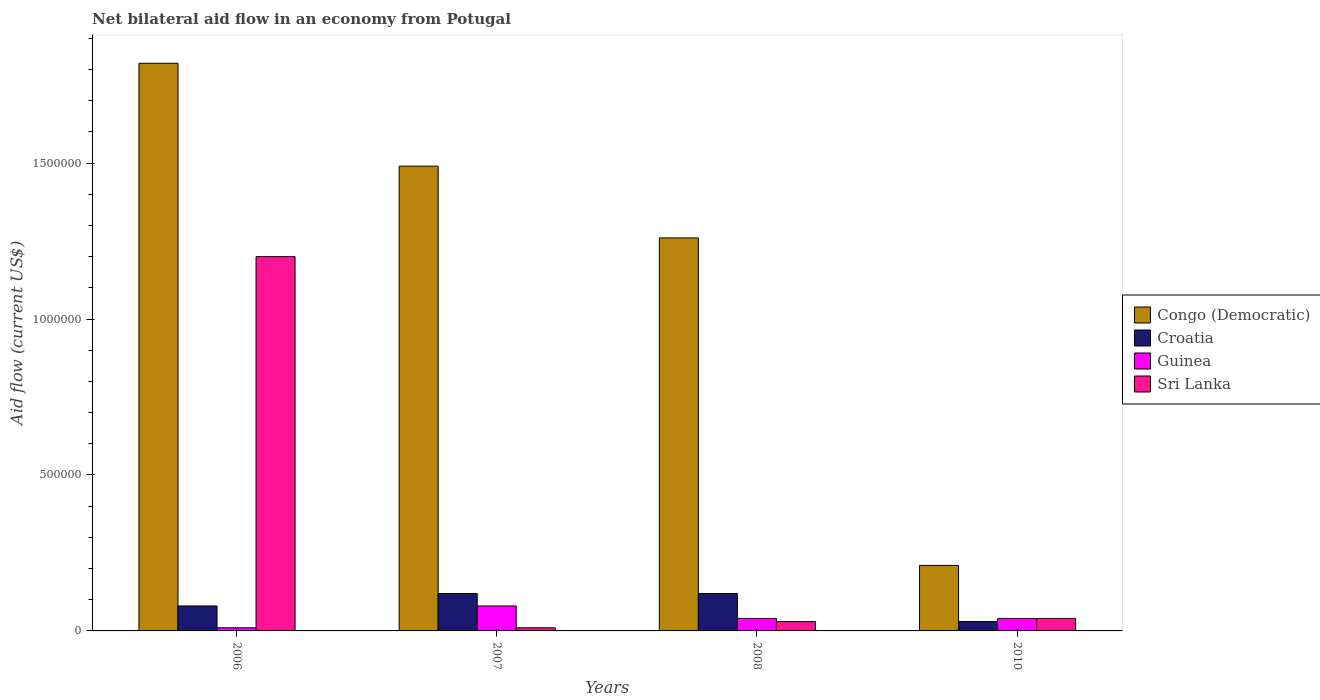How many different coloured bars are there?
Keep it short and to the point. 4. What is the label of the 2nd group of bars from the left?
Your response must be concise. 2007. In how many cases, is the number of bars for a given year not equal to the number of legend labels?
Your response must be concise. 0. Across all years, what is the maximum net bilateral aid flow in Guinea?
Your answer should be very brief. 8.00e+04. Across all years, what is the minimum net bilateral aid flow in Guinea?
Offer a very short reply. 10000. In which year was the net bilateral aid flow in Croatia maximum?
Provide a succinct answer. 2007. What is the total net bilateral aid flow in Sri Lanka in the graph?
Your answer should be compact. 1.28e+06. What is the difference between the net bilateral aid flow in Sri Lanka in 2007 and that in 2010?
Your answer should be compact. -3.00e+04. What is the difference between the net bilateral aid flow in Congo (Democratic) in 2008 and the net bilateral aid flow in Guinea in 2006?
Provide a short and direct response. 1.25e+06. What is the average net bilateral aid flow in Congo (Democratic) per year?
Your answer should be compact. 1.20e+06. In how many years, is the net bilateral aid flow in Sri Lanka greater than 1300000 US$?
Make the answer very short. 0. What is the ratio of the net bilateral aid flow in Guinea in 2008 to that in 2010?
Give a very brief answer. 1. What is the difference between the highest and the lowest net bilateral aid flow in Guinea?
Your answer should be compact. 7.00e+04. In how many years, is the net bilateral aid flow in Croatia greater than the average net bilateral aid flow in Croatia taken over all years?
Ensure brevity in your answer.  2. Is it the case that in every year, the sum of the net bilateral aid flow in Guinea and net bilateral aid flow in Sri Lanka is greater than the sum of net bilateral aid flow in Congo (Democratic) and net bilateral aid flow in Croatia?
Give a very brief answer. No. What does the 3rd bar from the left in 2010 represents?
Give a very brief answer. Guinea. What does the 1st bar from the right in 2010 represents?
Ensure brevity in your answer.  Sri Lanka. How many years are there in the graph?
Provide a succinct answer. 4. Are the values on the major ticks of Y-axis written in scientific E-notation?
Offer a terse response. No. Does the graph contain any zero values?
Offer a very short reply. No. Does the graph contain grids?
Your response must be concise. No. Where does the legend appear in the graph?
Make the answer very short. Center right. How many legend labels are there?
Ensure brevity in your answer.  4. How are the legend labels stacked?
Provide a succinct answer. Vertical. What is the title of the graph?
Ensure brevity in your answer.  Net bilateral aid flow in an economy from Potugal. Does "Turkey" appear as one of the legend labels in the graph?
Your answer should be compact. No. What is the label or title of the X-axis?
Give a very brief answer. Years. What is the label or title of the Y-axis?
Ensure brevity in your answer.  Aid flow (current US$). What is the Aid flow (current US$) of Congo (Democratic) in 2006?
Offer a very short reply. 1.82e+06. What is the Aid flow (current US$) in Croatia in 2006?
Make the answer very short. 8.00e+04. What is the Aid flow (current US$) of Sri Lanka in 2006?
Your answer should be compact. 1.20e+06. What is the Aid flow (current US$) of Congo (Democratic) in 2007?
Provide a succinct answer. 1.49e+06. What is the Aid flow (current US$) of Congo (Democratic) in 2008?
Provide a short and direct response. 1.26e+06. What is the Aid flow (current US$) of Croatia in 2008?
Ensure brevity in your answer.  1.20e+05. What is the Aid flow (current US$) of Guinea in 2008?
Your answer should be compact. 4.00e+04. What is the Aid flow (current US$) of Sri Lanka in 2008?
Provide a succinct answer. 3.00e+04. What is the Aid flow (current US$) in Congo (Democratic) in 2010?
Your answer should be compact. 2.10e+05. What is the Aid flow (current US$) in Croatia in 2010?
Provide a short and direct response. 3.00e+04. Across all years, what is the maximum Aid flow (current US$) in Congo (Democratic)?
Ensure brevity in your answer.  1.82e+06. Across all years, what is the maximum Aid flow (current US$) of Croatia?
Your answer should be compact. 1.20e+05. Across all years, what is the maximum Aid flow (current US$) in Guinea?
Give a very brief answer. 8.00e+04. Across all years, what is the maximum Aid flow (current US$) in Sri Lanka?
Provide a short and direct response. 1.20e+06. Across all years, what is the minimum Aid flow (current US$) of Guinea?
Give a very brief answer. 10000. Across all years, what is the minimum Aid flow (current US$) of Sri Lanka?
Keep it short and to the point. 10000. What is the total Aid flow (current US$) in Congo (Democratic) in the graph?
Your response must be concise. 4.78e+06. What is the total Aid flow (current US$) in Guinea in the graph?
Offer a terse response. 1.70e+05. What is the total Aid flow (current US$) of Sri Lanka in the graph?
Your answer should be very brief. 1.28e+06. What is the difference between the Aid flow (current US$) in Guinea in 2006 and that in 2007?
Offer a very short reply. -7.00e+04. What is the difference between the Aid flow (current US$) of Sri Lanka in 2006 and that in 2007?
Your answer should be compact. 1.19e+06. What is the difference between the Aid flow (current US$) of Congo (Democratic) in 2006 and that in 2008?
Provide a succinct answer. 5.60e+05. What is the difference between the Aid flow (current US$) of Sri Lanka in 2006 and that in 2008?
Give a very brief answer. 1.17e+06. What is the difference between the Aid flow (current US$) in Congo (Democratic) in 2006 and that in 2010?
Give a very brief answer. 1.61e+06. What is the difference between the Aid flow (current US$) in Sri Lanka in 2006 and that in 2010?
Your answer should be compact. 1.16e+06. What is the difference between the Aid flow (current US$) of Guinea in 2007 and that in 2008?
Ensure brevity in your answer.  4.00e+04. What is the difference between the Aid flow (current US$) of Sri Lanka in 2007 and that in 2008?
Your answer should be very brief. -2.00e+04. What is the difference between the Aid flow (current US$) of Congo (Democratic) in 2007 and that in 2010?
Keep it short and to the point. 1.28e+06. What is the difference between the Aid flow (current US$) of Guinea in 2007 and that in 2010?
Your answer should be very brief. 4.00e+04. What is the difference between the Aid flow (current US$) of Congo (Democratic) in 2008 and that in 2010?
Offer a terse response. 1.05e+06. What is the difference between the Aid flow (current US$) in Croatia in 2008 and that in 2010?
Offer a very short reply. 9.00e+04. What is the difference between the Aid flow (current US$) of Congo (Democratic) in 2006 and the Aid flow (current US$) of Croatia in 2007?
Your response must be concise. 1.70e+06. What is the difference between the Aid flow (current US$) of Congo (Democratic) in 2006 and the Aid flow (current US$) of Guinea in 2007?
Offer a very short reply. 1.74e+06. What is the difference between the Aid flow (current US$) in Congo (Democratic) in 2006 and the Aid flow (current US$) in Sri Lanka in 2007?
Give a very brief answer. 1.81e+06. What is the difference between the Aid flow (current US$) of Croatia in 2006 and the Aid flow (current US$) of Guinea in 2007?
Ensure brevity in your answer.  0. What is the difference between the Aid flow (current US$) of Croatia in 2006 and the Aid flow (current US$) of Sri Lanka in 2007?
Offer a terse response. 7.00e+04. What is the difference between the Aid flow (current US$) of Guinea in 2006 and the Aid flow (current US$) of Sri Lanka in 2007?
Provide a succinct answer. 0. What is the difference between the Aid flow (current US$) in Congo (Democratic) in 2006 and the Aid flow (current US$) in Croatia in 2008?
Make the answer very short. 1.70e+06. What is the difference between the Aid flow (current US$) in Congo (Democratic) in 2006 and the Aid flow (current US$) in Guinea in 2008?
Provide a short and direct response. 1.78e+06. What is the difference between the Aid flow (current US$) in Congo (Democratic) in 2006 and the Aid flow (current US$) in Sri Lanka in 2008?
Keep it short and to the point. 1.79e+06. What is the difference between the Aid flow (current US$) of Congo (Democratic) in 2006 and the Aid flow (current US$) of Croatia in 2010?
Ensure brevity in your answer.  1.79e+06. What is the difference between the Aid flow (current US$) in Congo (Democratic) in 2006 and the Aid flow (current US$) in Guinea in 2010?
Offer a terse response. 1.78e+06. What is the difference between the Aid flow (current US$) of Congo (Democratic) in 2006 and the Aid flow (current US$) of Sri Lanka in 2010?
Offer a terse response. 1.78e+06. What is the difference between the Aid flow (current US$) in Guinea in 2006 and the Aid flow (current US$) in Sri Lanka in 2010?
Your answer should be compact. -3.00e+04. What is the difference between the Aid flow (current US$) in Congo (Democratic) in 2007 and the Aid flow (current US$) in Croatia in 2008?
Give a very brief answer. 1.37e+06. What is the difference between the Aid flow (current US$) of Congo (Democratic) in 2007 and the Aid flow (current US$) of Guinea in 2008?
Offer a very short reply. 1.45e+06. What is the difference between the Aid flow (current US$) in Congo (Democratic) in 2007 and the Aid flow (current US$) in Sri Lanka in 2008?
Offer a very short reply. 1.46e+06. What is the difference between the Aid flow (current US$) of Croatia in 2007 and the Aid flow (current US$) of Guinea in 2008?
Offer a terse response. 8.00e+04. What is the difference between the Aid flow (current US$) in Croatia in 2007 and the Aid flow (current US$) in Sri Lanka in 2008?
Keep it short and to the point. 9.00e+04. What is the difference between the Aid flow (current US$) of Guinea in 2007 and the Aid flow (current US$) of Sri Lanka in 2008?
Your answer should be very brief. 5.00e+04. What is the difference between the Aid flow (current US$) of Congo (Democratic) in 2007 and the Aid flow (current US$) of Croatia in 2010?
Your answer should be compact. 1.46e+06. What is the difference between the Aid flow (current US$) of Congo (Democratic) in 2007 and the Aid flow (current US$) of Guinea in 2010?
Provide a succinct answer. 1.45e+06. What is the difference between the Aid flow (current US$) of Congo (Democratic) in 2007 and the Aid flow (current US$) of Sri Lanka in 2010?
Provide a succinct answer. 1.45e+06. What is the difference between the Aid flow (current US$) of Croatia in 2007 and the Aid flow (current US$) of Guinea in 2010?
Offer a terse response. 8.00e+04. What is the difference between the Aid flow (current US$) of Guinea in 2007 and the Aid flow (current US$) of Sri Lanka in 2010?
Provide a succinct answer. 4.00e+04. What is the difference between the Aid flow (current US$) of Congo (Democratic) in 2008 and the Aid flow (current US$) of Croatia in 2010?
Ensure brevity in your answer.  1.23e+06. What is the difference between the Aid flow (current US$) of Congo (Democratic) in 2008 and the Aid flow (current US$) of Guinea in 2010?
Provide a succinct answer. 1.22e+06. What is the difference between the Aid flow (current US$) in Congo (Democratic) in 2008 and the Aid flow (current US$) in Sri Lanka in 2010?
Make the answer very short. 1.22e+06. What is the difference between the Aid flow (current US$) in Croatia in 2008 and the Aid flow (current US$) in Guinea in 2010?
Offer a very short reply. 8.00e+04. What is the average Aid flow (current US$) of Congo (Democratic) per year?
Provide a short and direct response. 1.20e+06. What is the average Aid flow (current US$) in Croatia per year?
Offer a terse response. 8.75e+04. What is the average Aid flow (current US$) in Guinea per year?
Make the answer very short. 4.25e+04. What is the average Aid flow (current US$) in Sri Lanka per year?
Offer a very short reply. 3.20e+05. In the year 2006, what is the difference between the Aid flow (current US$) in Congo (Democratic) and Aid flow (current US$) in Croatia?
Offer a very short reply. 1.74e+06. In the year 2006, what is the difference between the Aid flow (current US$) of Congo (Democratic) and Aid flow (current US$) of Guinea?
Provide a succinct answer. 1.81e+06. In the year 2006, what is the difference between the Aid flow (current US$) in Congo (Democratic) and Aid flow (current US$) in Sri Lanka?
Offer a terse response. 6.20e+05. In the year 2006, what is the difference between the Aid flow (current US$) in Croatia and Aid flow (current US$) in Guinea?
Offer a very short reply. 7.00e+04. In the year 2006, what is the difference between the Aid flow (current US$) in Croatia and Aid flow (current US$) in Sri Lanka?
Keep it short and to the point. -1.12e+06. In the year 2006, what is the difference between the Aid flow (current US$) of Guinea and Aid flow (current US$) of Sri Lanka?
Keep it short and to the point. -1.19e+06. In the year 2007, what is the difference between the Aid flow (current US$) in Congo (Democratic) and Aid flow (current US$) in Croatia?
Offer a very short reply. 1.37e+06. In the year 2007, what is the difference between the Aid flow (current US$) in Congo (Democratic) and Aid flow (current US$) in Guinea?
Make the answer very short. 1.41e+06. In the year 2007, what is the difference between the Aid flow (current US$) in Congo (Democratic) and Aid flow (current US$) in Sri Lanka?
Ensure brevity in your answer.  1.48e+06. In the year 2007, what is the difference between the Aid flow (current US$) of Croatia and Aid flow (current US$) of Sri Lanka?
Your answer should be compact. 1.10e+05. In the year 2008, what is the difference between the Aid flow (current US$) of Congo (Democratic) and Aid flow (current US$) of Croatia?
Make the answer very short. 1.14e+06. In the year 2008, what is the difference between the Aid flow (current US$) of Congo (Democratic) and Aid flow (current US$) of Guinea?
Keep it short and to the point. 1.22e+06. In the year 2008, what is the difference between the Aid flow (current US$) of Congo (Democratic) and Aid flow (current US$) of Sri Lanka?
Offer a terse response. 1.23e+06. In the year 2008, what is the difference between the Aid flow (current US$) of Guinea and Aid flow (current US$) of Sri Lanka?
Provide a short and direct response. 10000. In the year 2010, what is the difference between the Aid flow (current US$) of Congo (Democratic) and Aid flow (current US$) of Sri Lanka?
Make the answer very short. 1.70e+05. In the year 2010, what is the difference between the Aid flow (current US$) in Croatia and Aid flow (current US$) in Sri Lanka?
Provide a succinct answer. -10000. In the year 2010, what is the difference between the Aid flow (current US$) in Guinea and Aid flow (current US$) in Sri Lanka?
Ensure brevity in your answer.  0. What is the ratio of the Aid flow (current US$) of Congo (Democratic) in 2006 to that in 2007?
Your answer should be very brief. 1.22. What is the ratio of the Aid flow (current US$) of Croatia in 2006 to that in 2007?
Offer a terse response. 0.67. What is the ratio of the Aid flow (current US$) of Guinea in 2006 to that in 2007?
Offer a very short reply. 0.12. What is the ratio of the Aid flow (current US$) of Sri Lanka in 2006 to that in 2007?
Make the answer very short. 120. What is the ratio of the Aid flow (current US$) of Congo (Democratic) in 2006 to that in 2008?
Provide a succinct answer. 1.44. What is the ratio of the Aid flow (current US$) of Croatia in 2006 to that in 2008?
Make the answer very short. 0.67. What is the ratio of the Aid flow (current US$) of Guinea in 2006 to that in 2008?
Your answer should be compact. 0.25. What is the ratio of the Aid flow (current US$) of Congo (Democratic) in 2006 to that in 2010?
Ensure brevity in your answer.  8.67. What is the ratio of the Aid flow (current US$) of Croatia in 2006 to that in 2010?
Offer a very short reply. 2.67. What is the ratio of the Aid flow (current US$) in Guinea in 2006 to that in 2010?
Your answer should be compact. 0.25. What is the ratio of the Aid flow (current US$) in Congo (Democratic) in 2007 to that in 2008?
Provide a short and direct response. 1.18. What is the ratio of the Aid flow (current US$) of Guinea in 2007 to that in 2008?
Make the answer very short. 2. What is the ratio of the Aid flow (current US$) of Congo (Democratic) in 2007 to that in 2010?
Provide a succinct answer. 7.1. What is the ratio of the Aid flow (current US$) of Guinea in 2007 to that in 2010?
Provide a short and direct response. 2. What is the ratio of the Aid flow (current US$) in Sri Lanka in 2007 to that in 2010?
Ensure brevity in your answer.  0.25. What is the ratio of the Aid flow (current US$) in Congo (Democratic) in 2008 to that in 2010?
Your answer should be compact. 6. What is the ratio of the Aid flow (current US$) of Croatia in 2008 to that in 2010?
Offer a very short reply. 4. What is the ratio of the Aid flow (current US$) in Guinea in 2008 to that in 2010?
Make the answer very short. 1. What is the ratio of the Aid flow (current US$) of Sri Lanka in 2008 to that in 2010?
Your answer should be compact. 0.75. What is the difference between the highest and the second highest Aid flow (current US$) of Croatia?
Give a very brief answer. 0. What is the difference between the highest and the second highest Aid flow (current US$) of Guinea?
Offer a very short reply. 4.00e+04. What is the difference between the highest and the second highest Aid flow (current US$) of Sri Lanka?
Your response must be concise. 1.16e+06. What is the difference between the highest and the lowest Aid flow (current US$) in Congo (Democratic)?
Ensure brevity in your answer.  1.61e+06. What is the difference between the highest and the lowest Aid flow (current US$) of Croatia?
Offer a terse response. 9.00e+04. What is the difference between the highest and the lowest Aid flow (current US$) in Guinea?
Offer a very short reply. 7.00e+04. What is the difference between the highest and the lowest Aid flow (current US$) of Sri Lanka?
Your answer should be compact. 1.19e+06. 